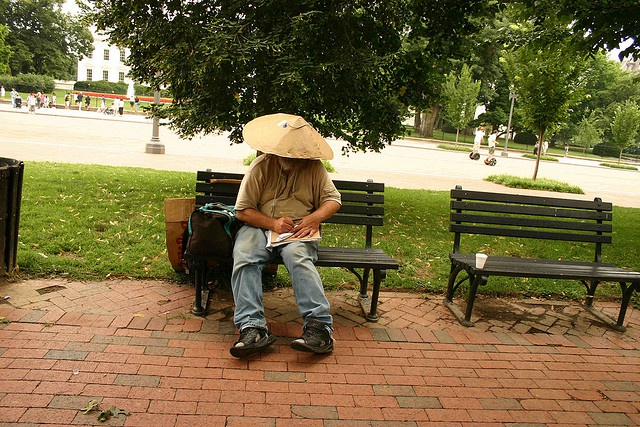Describe the objects in this image and their specific colors. I can see people in darkgreen, black, gray, khaki, and maroon tones, bench in darkgreen, black, and gray tones, bench in darkgreen, black, olive, and gray tones, backpack in darkgreen, black, gray, maroon, and darkgray tones, and people in darkgreen, ivory, tan, and khaki tones in this image. 